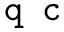Convert formula to latex. <formula><loc_0><loc_0><loc_500><loc_500>q c</formula> 